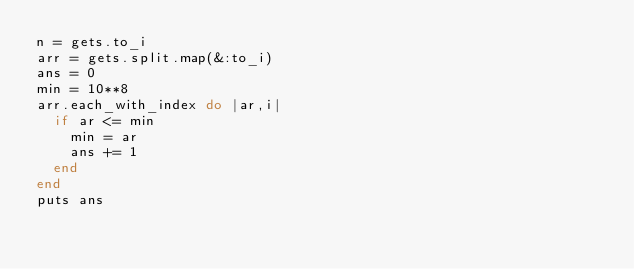Convert code to text. <code><loc_0><loc_0><loc_500><loc_500><_Ruby_>n = gets.to_i
arr = gets.split.map(&:to_i)
ans = 0
min = 10**8
arr.each_with_index do |ar,i|
  if ar <= min
    min = ar
    ans += 1
  end
end
puts ans
</code> 